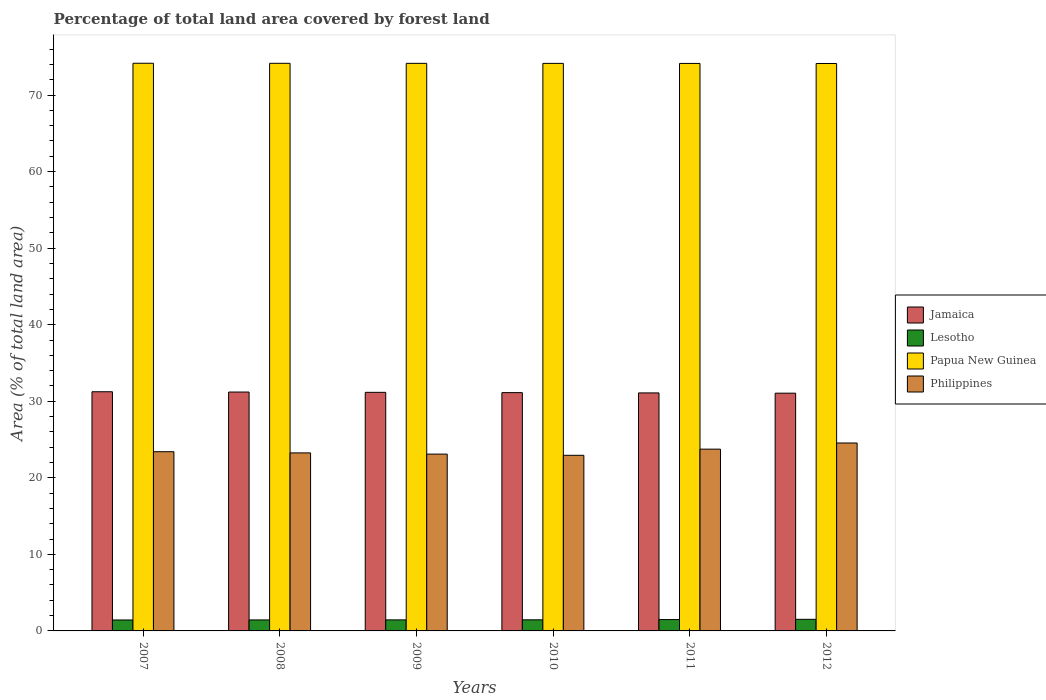Are the number of bars per tick equal to the number of legend labels?
Give a very brief answer. Yes. How many bars are there on the 3rd tick from the left?
Keep it short and to the point. 4. How many bars are there on the 4th tick from the right?
Your response must be concise. 4. What is the label of the 6th group of bars from the left?
Your answer should be very brief. 2012. What is the percentage of forest land in Philippines in 2007?
Provide a succinct answer. 23.41. Across all years, what is the maximum percentage of forest land in Lesotho?
Your answer should be very brief. 1.52. Across all years, what is the minimum percentage of forest land in Philippines?
Your response must be concise. 22.94. In which year was the percentage of forest land in Philippines minimum?
Your response must be concise. 2010. What is the total percentage of forest land in Lesotho in the graph?
Offer a terse response. 8.75. What is the difference between the percentage of forest land in Papua New Guinea in 2009 and that in 2010?
Provide a short and direct response. 0.01. What is the difference between the percentage of forest land in Philippines in 2007 and the percentage of forest land in Papua New Guinea in 2008?
Keep it short and to the point. -50.74. What is the average percentage of forest land in Jamaica per year?
Provide a short and direct response. 31.15. In the year 2007, what is the difference between the percentage of forest land in Lesotho and percentage of forest land in Philippines?
Make the answer very short. -21.98. What is the ratio of the percentage of forest land in Papua New Guinea in 2009 to that in 2010?
Offer a very short reply. 1. Is the percentage of forest land in Philippines in 2010 less than that in 2012?
Keep it short and to the point. Yes. Is the difference between the percentage of forest land in Lesotho in 2009 and 2010 greater than the difference between the percentage of forest land in Philippines in 2009 and 2010?
Provide a short and direct response. No. What is the difference between the highest and the second highest percentage of forest land in Jamaica?
Your response must be concise. 0.04. What is the difference between the highest and the lowest percentage of forest land in Papua New Guinea?
Offer a very short reply. 0.03. Is the sum of the percentage of forest land in Lesotho in 2010 and 2011 greater than the maximum percentage of forest land in Jamaica across all years?
Your response must be concise. No. Is it the case that in every year, the sum of the percentage of forest land in Philippines and percentage of forest land in Lesotho is greater than the sum of percentage of forest land in Jamaica and percentage of forest land in Papua New Guinea?
Offer a terse response. No. What does the 4th bar from the left in 2011 represents?
Your answer should be very brief. Philippines. What does the 3rd bar from the right in 2009 represents?
Give a very brief answer. Lesotho. Is it the case that in every year, the sum of the percentage of forest land in Jamaica and percentage of forest land in Lesotho is greater than the percentage of forest land in Philippines?
Give a very brief answer. Yes. How many bars are there?
Provide a short and direct response. 24. How many years are there in the graph?
Your answer should be compact. 6. Are the values on the major ticks of Y-axis written in scientific E-notation?
Ensure brevity in your answer.  No. How many legend labels are there?
Provide a succinct answer. 4. How are the legend labels stacked?
Ensure brevity in your answer.  Vertical. What is the title of the graph?
Offer a terse response. Percentage of total land area covered by forest land. Does "Slovenia" appear as one of the legend labels in the graph?
Give a very brief answer. No. What is the label or title of the X-axis?
Your answer should be compact. Years. What is the label or title of the Y-axis?
Your answer should be very brief. Area (% of total land area). What is the Area (% of total land area) in Jamaica in 2007?
Give a very brief answer. 31.24. What is the Area (% of total land area) in Lesotho in 2007?
Your answer should be very brief. 1.43. What is the Area (% of total land area) of Papua New Guinea in 2007?
Ensure brevity in your answer.  74.15. What is the Area (% of total land area) of Philippines in 2007?
Offer a terse response. 23.41. What is the Area (% of total land area) in Jamaica in 2008?
Offer a terse response. 31.2. What is the Area (% of total land area) of Lesotho in 2008?
Give a very brief answer. 1.44. What is the Area (% of total land area) in Papua New Guinea in 2008?
Your response must be concise. 74.15. What is the Area (% of total land area) of Philippines in 2008?
Your answer should be very brief. 23.25. What is the Area (% of total land area) of Jamaica in 2009?
Offer a very short reply. 31.17. What is the Area (% of total land area) of Lesotho in 2009?
Your response must be concise. 1.44. What is the Area (% of total land area) in Papua New Guinea in 2009?
Make the answer very short. 74.14. What is the Area (% of total land area) in Philippines in 2009?
Your response must be concise. 23.1. What is the Area (% of total land area) of Jamaica in 2010?
Offer a terse response. 31.13. What is the Area (% of total land area) of Lesotho in 2010?
Your answer should be compact. 1.45. What is the Area (% of total land area) in Papua New Guinea in 2010?
Ensure brevity in your answer.  74.14. What is the Area (% of total land area) of Philippines in 2010?
Your response must be concise. 22.94. What is the Area (% of total land area) of Jamaica in 2011?
Provide a short and direct response. 31.09. What is the Area (% of total land area) of Lesotho in 2011?
Keep it short and to the point. 1.48. What is the Area (% of total land area) of Papua New Guinea in 2011?
Keep it short and to the point. 74.13. What is the Area (% of total land area) in Philippines in 2011?
Provide a short and direct response. 23.74. What is the Area (% of total land area) of Jamaica in 2012?
Offer a terse response. 31.06. What is the Area (% of total land area) of Lesotho in 2012?
Your response must be concise. 1.52. What is the Area (% of total land area) in Papua New Guinea in 2012?
Make the answer very short. 74.12. What is the Area (% of total land area) in Philippines in 2012?
Your answer should be very brief. 24.55. Across all years, what is the maximum Area (% of total land area) in Jamaica?
Offer a very short reply. 31.24. Across all years, what is the maximum Area (% of total land area) of Lesotho?
Offer a terse response. 1.52. Across all years, what is the maximum Area (% of total land area) of Papua New Guinea?
Provide a succinct answer. 74.15. Across all years, what is the maximum Area (% of total land area) in Philippines?
Ensure brevity in your answer.  24.55. Across all years, what is the minimum Area (% of total land area) of Jamaica?
Offer a very short reply. 31.06. Across all years, what is the minimum Area (% of total land area) of Lesotho?
Your answer should be very brief. 1.43. Across all years, what is the minimum Area (% of total land area) of Papua New Guinea?
Make the answer very short. 74.12. Across all years, what is the minimum Area (% of total land area) of Philippines?
Your answer should be compact. 22.94. What is the total Area (% of total land area) in Jamaica in the graph?
Make the answer very short. 186.89. What is the total Area (% of total land area) of Lesotho in the graph?
Offer a very short reply. 8.75. What is the total Area (% of total land area) of Papua New Guinea in the graph?
Provide a succinct answer. 444.83. What is the total Area (% of total land area) in Philippines in the graph?
Keep it short and to the point. 141. What is the difference between the Area (% of total land area) in Jamaica in 2007 and that in 2008?
Keep it short and to the point. 0.04. What is the difference between the Area (% of total land area) of Lesotho in 2007 and that in 2008?
Give a very brief answer. -0.01. What is the difference between the Area (% of total land area) of Papua New Guinea in 2007 and that in 2008?
Your answer should be compact. 0.01. What is the difference between the Area (% of total land area) of Philippines in 2007 and that in 2008?
Your response must be concise. 0.16. What is the difference between the Area (% of total land area) of Jamaica in 2007 and that in 2009?
Your response must be concise. 0.08. What is the difference between the Area (% of total land area) in Lesotho in 2007 and that in 2009?
Offer a terse response. -0.01. What is the difference between the Area (% of total land area) of Papua New Guinea in 2007 and that in 2009?
Your answer should be compact. 0.01. What is the difference between the Area (% of total land area) of Philippines in 2007 and that in 2009?
Your response must be concise. 0.31. What is the difference between the Area (% of total land area) in Jamaica in 2007 and that in 2010?
Provide a short and direct response. 0.12. What is the difference between the Area (% of total land area) in Lesotho in 2007 and that in 2010?
Offer a terse response. -0.02. What is the difference between the Area (% of total land area) in Papua New Guinea in 2007 and that in 2010?
Provide a short and direct response. 0.02. What is the difference between the Area (% of total land area) of Philippines in 2007 and that in 2010?
Your response must be concise. 0.47. What is the difference between the Area (% of total land area) in Jamaica in 2007 and that in 2011?
Offer a terse response. 0.15. What is the difference between the Area (% of total land area) of Lesotho in 2007 and that in 2011?
Offer a terse response. -0.05. What is the difference between the Area (% of total land area) of Papua New Guinea in 2007 and that in 2011?
Give a very brief answer. 0.02. What is the difference between the Area (% of total land area) of Philippines in 2007 and that in 2011?
Give a very brief answer. -0.33. What is the difference between the Area (% of total land area) of Jamaica in 2007 and that in 2012?
Offer a terse response. 0.19. What is the difference between the Area (% of total land area) in Lesotho in 2007 and that in 2012?
Make the answer very short. -0.09. What is the difference between the Area (% of total land area) of Papua New Guinea in 2007 and that in 2012?
Your response must be concise. 0.03. What is the difference between the Area (% of total land area) in Philippines in 2007 and that in 2012?
Offer a very short reply. -1.14. What is the difference between the Area (% of total land area) of Jamaica in 2008 and that in 2009?
Offer a very short reply. 0.04. What is the difference between the Area (% of total land area) of Lesotho in 2008 and that in 2009?
Provide a succinct answer. -0.01. What is the difference between the Area (% of total land area) of Papua New Guinea in 2008 and that in 2009?
Ensure brevity in your answer.  0.01. What is the difference between the Area (% of total land area) of Philippines in 2008 and that in 2009?
Ensure brevity in your answer.  0.16. What is the difference between the Area (% of total land area) of Jamaica in 2008 and that in 2010?
Your response must be concise. 0.08. What is the difference between the Area (% of total land area) in Lesotho in 2008 and that in 2010?
Offer a terse response. -0.01. What is the difference between the Area (% of total land area) in Papua New Guinea in 2008 and that in 2010?
Make the answer very short. 0.01. What is the difference between the Area (% of total land area) of Philippines in 2008 and that in 2010?
Your answer should be very brief. 0.31. What is the difference between the Area (% of total land area) of Jamaica in 2008 and that in 2011?
Ensure brevity in your answer.  0.11. What is the difference between the Area (% of total land area) in Lesotho in 2008 and that in 2011?
Keep it short and to the point. -0.05. What is the difference between the Area (% of total land area) of Papua New Guinea in 2008 and that in 2011?
Keep it short and to the point. 0.02. What is the difference between the Area (% of total land area) of Philippines in 2008 and that in 2011?
Offer a terse response. -0.49. What is the difference between the Area (% of total land area) in Jamaica in 2008 and that in 2012?
Offer a terse response. 0.15. What is the difference between the Area (% of total land area) of Lesotho in 2008 and that in 2012?
Provide a succinct answer. -0.08. What is the difference between the Area (% of total land area) of Papua New Guinea in 2008 and that in 2012?
Make the answer very short. 0.02. What is the difference between the Area (% of total land area) in Philippines in 2008 and that in 2012?
Give a very brief answer. -1.3. What is the difference between the Area (% of total land area) of Jamaica in 2009 and that in 2010?
Offer a terse response. 0.04. What is the difference between the Area (% of total land area) of Lesotho in 2009 and that in 2010?
Keep it short and to the point. -0.01. What is the difference between the Area (% of total land area) of Papua New Guinea in 2009 and that in 2010?
Your answer should be compact. 0.01. What is the difference between the Area (% of total land area) of Philippines in 2009 and that in 2010?
Provide a short and direct response. 0.16. What is the difference between the Area (% of total land area) of Jamaica in 2009 and that in 2011?
Make the answer very short. 0.07. What is the difference between the Area (% of total land area) of Lesotho in 2009 and that in 2011?
Make the answer very short. -0.04. What is the difference between the Area (% of total land area) of Papua New Guinea in 2009 and that in 2011?
Provide a succinct answer. 0.01. What is the difference between the Area (% of total land area) in Philippines in 2009 and that in 2011?
Offer a very short reply. -0.65. What is the difference between the Area (% of total land area) in Jamaica in 2009 and that in 2012?
Keep it short and to the point. 0.11. What is the difference between the Area (% of total land area) of Lesotho in 2009 and that in 2012?
Make the answer very short. -0.07. What is the difference between the Area (% of total land area) of Papua New Guinea in 2009 and that in 2012?
Give a very brief answer. 0.02. What is the difference between the Area (% of total land area) in Philippines in 2009 and that in 2012?
Make the answer very short. -1.45. What is the difference between the Area (% of total land area) of Jamaica in 2010 and that in 2011?
Your answer should be compact. 0.04. What is the difference between the Area (% of total land area) of Lesotho in 2010 and that in 2011?
Provide a short and direct response. -0.03. What is the difference between the Area (% of total land area) of Papua New Guinea in 2010 and that in 2011?
Your response must be concise. 0.01. What is the difference between the Area (% of total land area) of Philippines in 2010 and that in 2011?
Your answer should be compact. -0.8. What is the difference between the Area (% of total land area) in Jamaica in 2010 and that in 2012?
Give a very brief answer. 0.07. What is the difference between the Area (% of total land area) in Lesotho in 2010 and that in 2012?
Your answer should be compact. -0.07. What is the difference between the Area (% of total land area) in Papua New Guinea in 2010 and that in 2012?
Give a very brief answer. 0.01. What is the difference between the Area (% of total land area) in Philippines in 2010 and that in 2012?
Your answer should be very brief. -1.61. What is the difference between the Area (% of total land area) of Jamaica in 2011 and that in 2012?
Make the answer very short. 0.04. What is the difference between the Area (% of total land area) of Lesotho in 2011 and that in 2012?
Your answer should be very brief. -0.03. What is the difference between the Area (% of total land area) in Papua New Guinea in 2011 and that in 2012?
Give a very brief answer. 0.01. What is the difference between the Area (% of total land area) in Philippines in 2011 and that in 2012?
Offer a terse response. -0.8. What is the difference between the Area (% of total land area) in Jamaica in 2007 and the Area (% of total land area) in Lesotho in 2008?
Make the answer very short. 29.81. What is the difference between the Area (% of total land area) in Jamaica in 2007 and the Area (% of total land area) in Papua New Guinea in 2008?
Your answer should be compact. -42.9. What is the difference between the Area (% of total land area) of Jamaica in 2007 and the Area (% of total land area) of Philippines in 2008?
Provide a succinct answer. 7.99. What is the difference between the Area (% of total land area) in Lesotho in 2007 and the Area (% of total land area) in Papua New Guinea in 2008?
Offer a terse response. -72.72. What is the difference between the Area (% of total land area) in Lesotho in 2007 and the Area (% of total land area) in Philippines in 2008?
Provide a succinct answer. -21.82. What is the difference between the Area (% of total land area) in Papua New Guinea in 2007 and the Area (% of total land area) in Philippines in 2008?
Make the answer very short. 50.9. What is the difference between the Area (% of total land area) of Jamaica in 2007 and the Area (% of total land area) of Lesotho in 2009?
Ensure brevity in your answer.  29.8. What is the difference between the Area (% of total land area) of Jamaica in 2007 and the Area (% of total land area) of Papua New Guinea in 2009?
Make the answer very short. -42.9. What is the difference between the Area (% of total land area) in Jamaica in 2007 and the Area (% of total land area) in Philippines in 2009?
Make the answer very short. 8.15. What is the difference between the Area (% of total land area) in Lesotho in 2007 and the Area (% of total land area) in Papua New Guinea in 2009?
Your answer should be compact. -72.71. What is the difference between the Area (% of total land area) of Lesotho in 2007 and the Area (% of total land area) of Philippines in 2009?
Provide a succinct answer. -21.67. What is the difference between the Area (% of total land area) in Papua New Guinea in 2007 and the Area (% of total land area) in Philippines in 2009?
Make the answer very short. 51.06. What is the difference between the Area (% of total land area) in Jamaica in 2007 and the Area (% of total land area) in Lesotho in 2010?
Offer a very short reply. 29.79. What is the difference between the Area (% of total land area) in Jamaica in 2007 and the Area (% of total land area) in Papua New Guinea in 2010?
Your answer should be very brief. -42.89. What is the difference between the Area (% of total land area) in Jamaica in 2007 and the Area (% of total land area) in Philippines in 2010?
Provide a succinct answer. 8.3. What is the difference between the Area (% of total land area) in Lesotho in 2007 and the Area (% of total land area) in Papua New Guinea in 2010?
Give a very brief answer. -72.71. What is the difference between the Area (% of total land area) in Lesotho in 2007 and the Area (% of total land area) in Philippines in 2010?
Provide a short and direct response. -21.51. What is the difference between the Area (% of total land area) in Papua New Guinea in 2007 and the Area (% of total land area) in Philippines in 2010?
Your answer should be very brief. 51.21. What is the difference between the Area (% of total land area) in Jamaica in 2007 and the Area (% of total land area) in Lesotho in 2011?
Ensure brevity in your answer.  29.76. What is the difference between the Area (% of total land area) of Jamaica in 2007 and the Area (% of total land area) of Papua New Guinea in 2011?
Provide a succinct answer. -42.89. What is the difference between the Area (% of total land area) in Jamaica in 2007 and the Area (% of total land area) in Philippines in 2011?
Your response must be concise. 7.5. What is the difference between the Area (% of total land area) in Lesotho in 2007 and the Area (% of total land area) in Papua New Guinea in 2011?
Provide a short and direct response. -72.7. What is the difference between the Area (% of total land area) in Lesotho in 2007 and the Area (% of total land area) in Philippines in 2011?
Keep it short and to the point. -22.32. What is the difference between the Area (% of total land area) of Papua New Guinea in 2007 and the Area (% of total land area) of Philippines in 2011?
Your answer should be compact. 50.41. What is the difference between the Area (% of total land area) of Jamaica in 2007 and the Area (% of total land area) of Lesotho in 2012?
Provide a succinct answer. 29.73. What is the difference between the Area (% of total land area) of Jamaica in 2007 and the Area (% of total land area) of Papua New Guinea in 2012?
Give a very brief answer. -42.88. What is the difference between the Area (% of total land area) of Jamaica in 2007 and the Area (% of total land area) of Philippines in 2012?
Provide a short and direct response. 6.69. What is the difference between the Area (% of total land area) in Lesotho in 2007 and the Area (% of total land area) in Papua New Guinea in 2012?
Give a very brief answer. -72.69. What is the difference between the Area (% of total land area) in Lesotho in 2007 and the Area (% of total land area) in Philippines in 2012?
Offer a very short reply. -23.12. What is the difference between the Area (% of total land area) of Papua New Guinea in 2007 and the Area (% of total land area) of Philippines in 2012?
Provide a succinct answer. 49.6. What is the difference between the Area (% of total land area) of Jamaica in 2008 and the Area (% of total land area) of Lesotho in 2009?
Your answer should be compact. 29.76. What is the difference between the Area (% of total land area) in Jamaica in 2008 and the Area (% of total land area) in Papua New Guinea in 2009?
Offer a very short reply. -42.94. What is the difference between the Area (% of total land area) in Jamaica in 2008 and the Area (% of total land area) in Philippines in 2009?
Provide a succinct answer. 8.11. What is the difference between the Area (% of total land area) of Lesotho in 2008 and the Area (% of total land area) of Papua New Guinea in 2009?
Your answer should be very brief. -72.71. What is the difference between the Area (% of total land area) in Lesotho in 2008 and the Area (% of total land area) in Philippines in 2009?
Provide a succinct answer. -21.66. What is the difference between the Area (% of total land area) of Papua New Guinea in 2008 and the Area (% of total land area) of Philippines in 2009?
Your response must be concise. 51.05. What is the difference between the Area (% of total land area) of Jamaica in 2008 and the Area (% of total land area) of Lesotho in 2010?
Make the answer very short. 29.75. What is the difference between the Area (% of total land area) of Jamaica in 2008 and the Area (% of total land area) of Papua New Guinea in 2010?
Offer a terse response. -42.93. What is the difference between the Area (% of total land area) in Jamaica in 2008 and the Area (% of total land area) in Philippines in 2010?
Provide a succinct answer. 8.26. What is the difference between the Area (% of total land area) in Lesotho in 2008 and the Area (% of total land area) in Papua New Guinea in 2010?
Provide a succinct answer. -72.7. What is the difference between the Area (% of total land area) in Lesotho in 2008 and the Area (% of total land area) in Philippines in 2010?
Ensure brevity in your answer.  -21.5. What is the difference between the Area (% of total land area) in Papua New Guinea in 2008 and the Area (% of total land area) in Philippines in 2010?
Offer a terse response. 51.21. What is the difference between the Area (% of total land area) of Jamaica in 2008 and the Area (% of total land area) of Lesotho in 2011?
Make the answer very short. 29.72. What is the difference between the Area (% of total land area) of Jamaica in 2008 and the Area (% of total land area) of Papua New Guinea in 2011?
Keep it short and to the point. -42.93. What is the difference between the Area (% of total land area) in Jamaica in 2008 and the Area (% of total land area) in Philippines in 2011?
Keep it short and to the point. 7.46. What is the difference between the Area (% of total land area) of Lesotho in 2008 and the Area (% of total land area) of Papua New Guinea in 2011?
Offer a very short reply. -72.69. What is the difference between the Area (% of total land area) of Lesotho in 2008 and the Area (% of total land area) of Philippines in 2011?
Your answer should be very brief. -22.31. What is the difference between the Area (% of total land area) of Papua New Guinea in 2008 and the Area (% of total land area) of Philippines in 2011?
Offer a terse response. 50.4. What is the difference between the Area (% of total land area) in Jamaica in 2008 and the Area (% of total land area) in Lesotho in 2012?
Ensure brevity in your answer.  29.69. What is the difference between the Area (% of total land area) in Jamaica in 2008 and the Area (% of total land area) in Papua New Guinea in 2012?
Your response must be concise. -42.92. What is the difference between the Area (% of total land area) in Jamaica in 2008 and the Area (% of total land area) in Philippines in 2012?
Ensure brevity in your answer.  6.65. What is the difference between the Area (% of total land area) of Lesotho in 2008 and the Area (% of total land area) of Papua New Guinea in 2012?
Offer a very short reply. -72.69. What is the difference between the Area (% of total land area) in Lesotho in 2008 and the Area (% of total land area) in Philippines in 2012?
Make the answer very short. -23.11. What is the difference between the Area (% of total land area) of Papua New Guinea in 2008 and the Area (% of total land area) of Philippines in 2012?
Provide a short and direct response. 49.6. What is the difference between the Area (% of total land area) of Jamaica in 2009 and the Area (% of total land area) of Lesotho in 2010?
Your response must be concise. 29.72. What is the difference between the Area (% of total land area) in Jamaica in 2009 and the Area (% of total land area) in Papua New Guinea in 2010?
Provide a short and direct response. -42.97. What is the difference between the Area (% of total land area) in Jamaica in 2009 and the Area (% of total land area) in Philippines in 2010?
Provide a short and direct response. 8.23. What is the difference between the Area (% of total land area) of Lesotho in 2009 and the Area (% of total land area) of Papua New Guinea in 2010?
Offer a very short reply. -72.69. What is the difference between the Area (% of total land area) of Lesotho in 2009 and the Area (% of total land area) of Philippines in 2010?
Ensure brevity in your answer.  -21.5. What is the difference between the Area (% of total land area) in Papua New Guinea in 2009 and the Area (% of total land area) in Philippines in 2010?
Ensure brevity in your answer.  51.2. What is the difference between the Area (% of total land area) in Jamaica in 2009 and the Area (% of total land area) in Lesotho in 2011?
Provide a succinct answer. 29.68. What is the difference between the Area (% of total land area) of Jamaica in 2009 and the Area (% of total land area) of Papua New Guinea in 2011?
Offer a terse response. -42.96. What is the difference between the Area (% of total land area) in Jamaica in 2009 and the Area (% of total land area) in Philippines in 2011?
Your answer should be compact. 7.42. What is the difference between the Area (% of total land area) in Lesotho in 2009 and the Area (% of total land area) in Papua New Guinea in 2011?
Make the answer very short. -72.69. What is the difference between the Area (% of total land area) in Lesotho in 2009 and the Area (% of total land area) in Philippines in 2011?
Your response must be concise. -22.3. What is the difference between the Area (% of total land area) in Papua New Guinea in 2009 and the Area (% of total land area) in Philippines in 2011?
Offer a terse response. 50.4. What is the difference between the Area (% of total land area) in Jamaica in 2009 and the Area (% of total land area) in Lesotho in 2012?
Give a very brief answer. 29.65. What is the difference between the Area (% of total land area) in Jamaica in 2009 and the Area (% of total land area) in Papua New Guinea in 2012?
Ensure brevity in your answer.  -42.96. What is the difference between the Area (% of total land area) of Jamaica in 2009 and the Area (% of total land area) of Philippines in 2012?
Your answer should be compact. 6.62. What is the difference between the Area (% of total land area) in Lesotho in 2009 and the Area (% of total land area) in Papua New Guinea in 2012?
Ensure brevity in your answer.  -72.68. What is the difference between the Area (% of total land area) of Lesotho in 2009 and the Area (% of total land area) of Philippines in 2012?
Your answer should be compact. -23.11. What is the difference between the Area (% of total land area) in Papua New Guinea in 2009 and the Area (% of total land area) in Philippines in 2012?
Make the answer very short. 49.59. What is the difference between the Area (% of total land area) of Jamaica in 2010 and the Area (% of total land area) of Lesotho in 2011?
Provide a succinct answer. 29.64. What is the difference between the Area (% of total land area) of Jamaica in 2010 and the Area (% of total land area) of Papua New Guinea in 2011?
Your response must be concise. -43. What is the difference between the Area (% of total land area) of Jamaica in 2010 and the Area (% of total land area) of Philippines in 2011?
Your answer should be compact. 7.38. What is the difference between the Area (% of total land area) of Lesotho in 2010 and the Area (% of total land area) of Papua New Guinea in 2011?
Ensure brevity in your answer.  -72.68. What is the difference between the Area (% of total land area) of Lesotho in 2010 and the Area (% of total land area) of Philippines in 2011?
Your response must be concise. -22.3. What is the difference between the Area (% of total land area) in Papua New Guinea in 2010 and the Area (% of total land area) in Philippines in 2011?
Provide a short and direct response. 50.39. What is the difference between the Area (% of total land area) of Jamaica in 2010 and the Area (% of total land area) of Lesotho in 2012?
Keep it short and to the point. 29.61. What is the difference between the Area (% of total land area) of Jamaica in 2010 and the Area (% of total land area) of Papua New Guinea in 2012?
Provide a succinct answer. -43. What is the difference between the Area (% of total land area) in Jamaica in 2010 and the Area (% of total land area) in Philippines in 2012?
Give a very brief answer. 6.58. What is the difference between the Area (% of total land area) of Lesotho in 2010 and the Area (% of total land area) of Papua New Guinea in 2012?
Your answer should be very brief. -72.67. What is the difference between the Area (% of total land area) in Lesotho in 2010 and the Area (% of total land area) in Philippines in 2012?
Your answer should be compact. -23.1. What is the difference between the Area (% of total land area) of Papua New Guinea in 2010 and the Area (% of total land area) of Philippines in 2012?
Ensure brevity in your answer.  49.59. What is the difference between the Area (% of total land area) in Jamaica in 2011 and the Area (% of total land area) in Lesotho in 2012?
Keep it short and to the point. 29.58. What is the difference between the Area (% of total land area) of Jamaica in 2011 and the Area (% of total land area) of Papua New Guinea in 2012?
Offer a very short reply. -43.03. What is the difference between the Area (% of total land area) of Jamaica in 2011 and the Area (% of total land area) of Philippines in 2012?
Ensure brevity in your answer.  6.54. What is the difference between the Area (% of total land area) in Lesotho in 2011 and the Area (% of total land area) in Papua New Guinea in 2012?
Ensure brevity in your answer.  -72.64. What is the difference between the Area (% of total land area) in Lesotho in 2011 and the Area (% of total land area) in Philippines in 2012?
Make the answer very short. -23.07. What is the difference between the Area (% of total land area) in Papua New Guinea in 2011 and the Area (% of total land area) in Philippines in 2012?
Give a very brief answer. 49.58. What is the average Area (% of total land area) in Jamaica per year?
Your answer should be compact. 31.15. What is the average Area (% of total land area) in Lesotho per year?
Offer a terse response. 1.46. What is the average Area (% of total land area) of Papua New Guinea per year?
Your answer should be compact. 74.14. What is the average Area (% of total land area) in Philippines per year?
Ensure brevity in your answer.  23.5. In the year 2007, what is the difference between the Area (% of total land area) of Jamaica and Area (% of total land area) of Lesotho?
Provide a short and direct response. 29.81. In the year 2007, what is the difference between the Area (% of total land area) in Jamaica and Area (% of total land area) in Papua New Guinea?
Ensure brevity in your answer.  -42.91. In the year 2007, what is the difference between the Area (% of total land area) in Jamaica and Area (% of total land area) in Philippines?
Offer a terse response. 7.83. In the year 2007, what is the difference between the Area (% of total land area) of Lesotho and Area (% of total land area) of Papua New Guinea?
Your response must be concise. -72.72. In the year 2007, what is the difference between the Area (% of total land area) of Lesotho and Area (% of total land area) of Philippines?
Provide a succinct answer. -21.98. In the year 2007, what is the difference between the Area (% of total land area) of Papua New Guinea and Area (% of total land area) of Philippines?
Give a very brief answer. 50.74. In the year 2008, what is the difference between the Area (% of total land area) of Jamaica and Area (% of total land area) of Lesotho?
Ensure brevity in your answer.  29.77. In the year 2008, what is the difference between the Area (% of total land area) of Jamaica and Area (% of total land area) of Papua New Guinea?
Provide a succinct answer. -42.94. In the year 2008, what is the difference between the Area (% of total land area) in Jamaica and Area (% of total land area) in Philippines?
Ensure brevity in your answer.  7.95. In the year 2008, what is the difference between the Area (% of total land area) in Lesotho and Area (% of total land area) in Papua New Guinea?
Your response must be concise. -72.71. In the year 2008, what is the difference between the Area (% of total land area) in Lesotho and Area (% of total land area) in Philippines?
Keep it short and to the point. -21.82. In the year 2008, what is the difference between the Area (% of total land area) in Papua New Guinea and Area (% of total land area) in Philippines?
Offer a terse response. 50.89. In the year 2009, what is the difference between the Area (% of total land area) in Jamaica and Area (% of total land area) in Lesotho?
Your answer should be compact. 29.72. In the year 2009, what is the difference between the Area (% of total land area) of Jamaica and Area (% of total land area) of Papua New Guinea?
Your answer should be compact. -42.98. In the year 2009, what is the difference between the Area (% of total land area) of Jamaica and Area (% of total land area) of Philippines?
Keep it short and to the point. 8.07. In the year 2009, what is the difference between the Area (% of total land area) of Lesotho and Area (% of total land area) of Papua New Guinea?
Make the answer very short. -72.7. In the year 2009, what is the difference between the Area (% of total land area) of Lesotho and Area (% of total land area) of Philippines?
Make the answer very short. -21.65. In the year 2009, what is the difference between the Area (% of total land area) of Papua New Guinea and Area (% of total land area) of Philippines?
Offer a terse response. 51.04. In the year 2010, what is the difference between the Area (% of total land area) in Jamaica and Area (% of total land area) in Lesotho?
Your answer should be compact. 29.68. In the year 2010, what is the difference between the Area (% of total land area) in Jamaica and Area (% of total land area) in Papua New Guinea?
Make the answer very short. -43.01. In the year 2010, what is the difference between the Area (% of total land area) of Jamaica and Area (% of total land area) of Philippines?
Make the answer very short. 8.19. In the year 2010, what is the difference between the Area (% of total land area) in Lesotho and Area (% of total land area) in Papua New Guinea?
Offer a terse response. -72.69. In the year 2010, what is the difference between the Area (% of total land area) of Lesotho and Area (% of total land area) of Philippines?
Ensure brevity in your answer.  -21.49. In the year 2010, what is the difference between the Area (% of total land area) in Papua New Guinea and Area (% of total land area) in Philippines?
Your answer should be compact. 51.2. In the year 2011, what is the difference between the Area (% of total land area) of Jamaica and Area (% of total land area) of Lesotho?
Offer a terse response. 29.61. In the year 2011, what is the difference between the Area (% of total land area) of Jamaica and Area (% of total land area) of Papua New Guinea?
Your response must be concise. -43.04. In the year 2011, what is the difference between the Area (% of total land area) in Jamaica and Area (% of total land area) in Philippines?
Provide a succinct answer. 7.35. In the year 2011, what is the difference between the Area (% of total land area) in Lesotho and Area (% of total land area) in Papua New Guinea?
Offer a very short reply. -72.65. In the year 2011, what is the difference between the Area (% of total land area) of Lesotho and Area (% of total land area) of Philippines?
Your answer should be compact. -22.26. In the year 2011, what is the difference between the Area (% of total land area) of Papua New Guinea and Area (% of total land area) of Philippines?
Give a very brief answer. 50.38. In the year 2012, what is the difference between the Area (% of total land area) in Jamaica and Area (% of total land area) in Lesotho?
Make the answer very short. 29.54. In the year 2012, what is the difference between the Area (% of total land area) in Jamaica and Area (% of total land area) in Papua New Guinea?
Ensure brevity in your answer.  -43.07. In the year 2012, what is the difference between the Area (% of total land area) of Jamaica and Area (% of total land area) of Philippines?
Provide a short and direct response. 6.51. In the year 2012, what is the difference between the Area (% of total land area) of Lesotho and Area (% of total land area) of Papua New Guinea?
Make the answer very short. -72.61. In the year 2012, what is the difference between the Area (% of total land area) in Lesotho and Area (% of total land area) in Philippines?
Your response must be concise. -23.03. In the year 2012, what is the difference between the Area (% of total land area) in Papua New Guinea and Area (% of total land area) in Philippines?
Make the answer very short. 49.57. What is the ratio of the Area (% of total land area) in Lesotho in 2007 to that in 2008?
Your answer should be compact. 1. What is the ratio of the Area (% of total land area) of Lesotho in 2007 to that in 2009?
Ensure brevity in your answer.  0.99. What is the ratio of the Area (% of total land area) in Philippines in 2007 to that in 2009?
Your answer should be compact. 1.01. What is the ratio of the Area (% of total land area) in Jamaica in 2007 to that in 2010?
Your response must be concise. 1. What is the ratio of the Area (% of total land area) of Lesotho in 2007 to that in 2010?
Make the answer very short. 0.99. What is the ratio of the Area (% of total land area) of Philippines in 2007 to that in 2010?
Give a very brief answer. 1.02. What is the ratio of the Area (% of total land area) in Lesotho in 2007 to that in 2011?
Provide a succinct answer. 0.96. What is the ratio of the Area (% of total land area) of Philippines in 2007 to that in 2011?
Your answer should be very brief. 0.99. What is the ratio of the Area (% of total land area) in Lesotho in 2007 to that in 2012?
Provide a succinct answer. 0.94. What is the ratio of the Area (% of total land area) of Philippines in 2007 to that in 2012?
Make the answer very short. 0.95. What is the ratio of the Area (% of total land area) of Philippines in 2008 to that in 2009?
Give a very brief answer. 1.01. What is the ratio of the Area (% of total land area) in Lesotho in 2008 to that in 2010?
Provide a succinct answer. 0.99. What is the ratio of the Area (% of total land area) in Philippines in 2008 to that in 2010?
Ensure brevity in your answer.  1.01. What is the ratio of the Area (% of total land area) in Lesotho in 2008 to that in 2011?
Keep it short and to the point. 0.97. What is the ratio of the Area (% of total land area) of Papua New Guinea in 2008 to that in 2011?
Keep it short and to the point. 1. What is the ratio of the Area (% of total land area) of Philippines in 2008 to that in 2011?
Provide a succinct answer. 0.98. What is the ratio of the Area (% of total land area) of Lesotho in 2008 to that in 2012?
Give a very brief answer. 0.95. What is the ratio of the Area (% of total land area) of Papua New Guinea in 2008 to that in 2012?
Offer a terse response. 1. What is the ratio of the Area (% of total land area) in Philippines in 2008 to that in 2012?
Your response must be concise. 0.95. What is the ratio of the Area (% of total land area) of Lesotho in 2009 to that in 2010?
Provide a short and direct response. 1. What is the ratio of the Area (% of total land area) of Philippines in 2009 to that in 2010?
Your answer should be very brief. 1.01. What is the ratio of the Area (% of total land area) in Jamaica in 2009 to that in 2011?
Your answer should be compact. 1. What is the ratio of the Area (% of total land area) in Lesotho in 2009 to that in 2011?
Your answer should be compact. 0.97. What is the ratio of the Area (% of total land area) of Philippines in 2009 to that in 2011?
Give a very brief answer. 0.97. What is the ratio of the Area (% of total land area) of Lesotho in 2009 to that in 2012?
Your answer should be very brief. 0.95. What is the ratio of the Area (% of total land area) of Philippines in 2009 to that in 2012?
Provide a succinct answer. 0.94. What is the ratio of the Area (% of total land area) of Lesotho in 2010 to that in 2011?
Give a very brief answer. 0.98. What is the ratio of the Area (% of total land area) of Philippines in 2010 to that in 2011?
Provide a succinct answer. 0.97. What is the ratio of the Area (% of total land area) of Lesotho in 2010 to that in 2012?
Offer a terse response. 0.96. What is the ratio of the Area (% of total land area) in Philippines in 2010 to that in 2012?
Offer a very short reply. 0.93. What is the ratio of the Area (% of total land area) of Jamaica in 2011 to that in 2012?
Your answer should be very brief. 1. What is the ratio of the Area (% of total land area) in Lesotho in 2011 to that in 2012?
Offer a terse response. 0.98. What is the ratio of the Area (% of total land area) in Philippines in 2011 to that in 2012?
Your response must be concise. 0.97. What is the difference between the highest and the second highest Area (% of total land area) in Jamaica?
Ensure brevity in your answer.  0.04. What is the difference between the highest and the second highest Area (% of total land area) in Lesotho?
Make the answer very short. 0.03. What is the difference between the highest and the second highest Area (% of total land area) in Papua New Guinea?
Ensure brevity in your answer.  0.01. What is the difference between the highest and the second highest Area (% of total land area) of Philippines?
Your answer should be compact. 0.8. What is the difference between the highest and the lowest Area (% of total land area) of Jamaica?
Make the answer very short. 0.19. What is the difference between the highest and the lowest Area (% of total land area) in Lesotho?
Ensure brevity in your answer.  0.09. What is the difference between the highest and the lowest Area (% of total land area) of Papua New Guinea?
Make the answer very short. 0.03. What is the difference between the highest and the lowest Area (% of total land area) of Philippines?
Offer a very short reply. 1.61. 